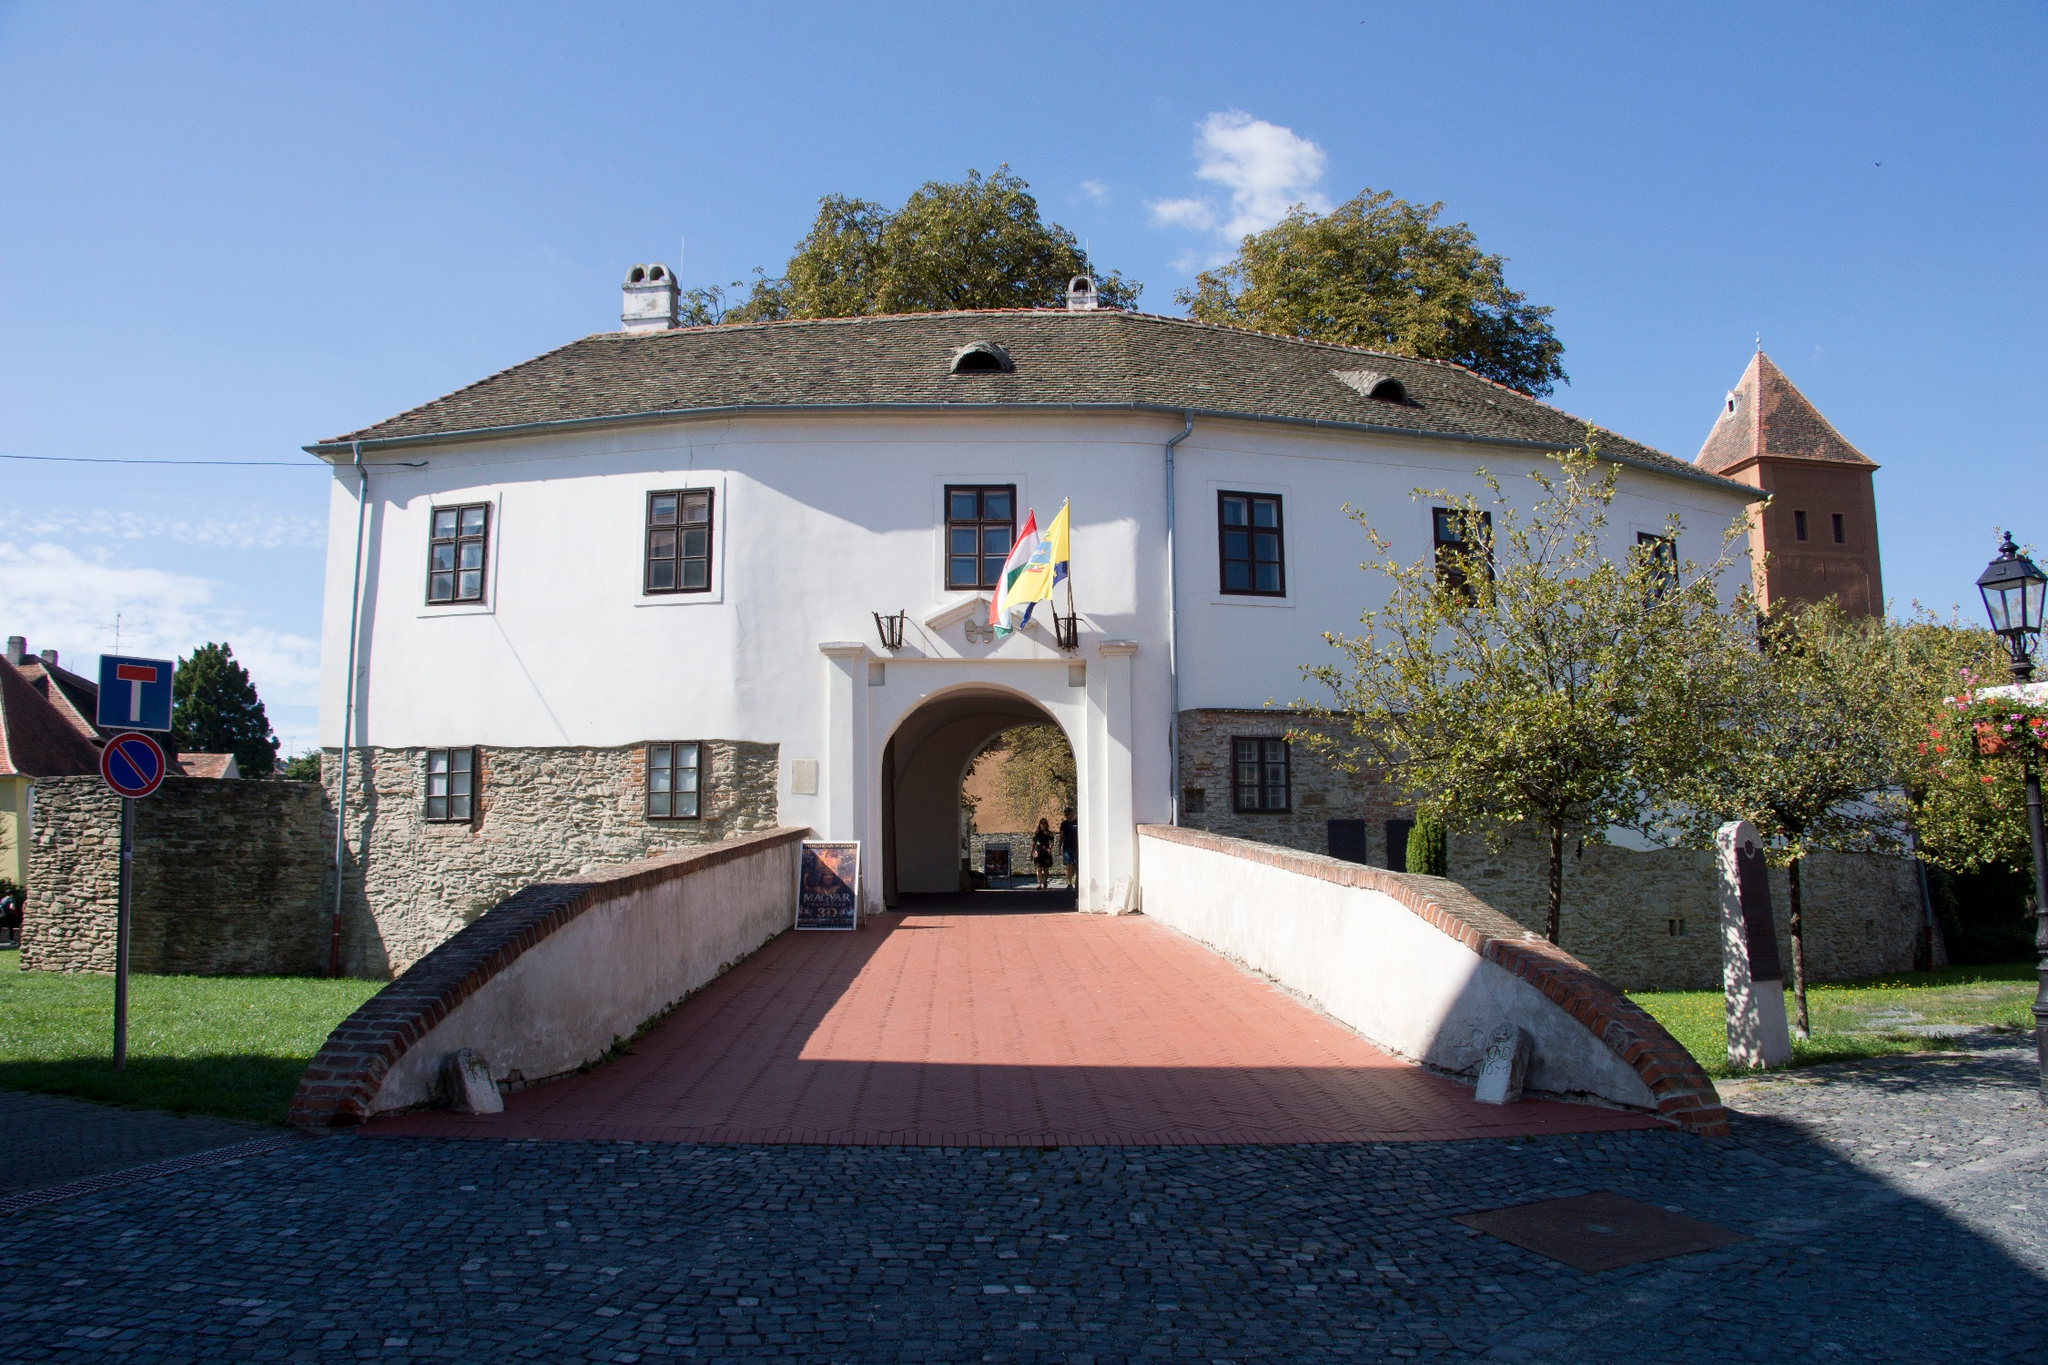Speculate on what hidden secrets this church might hold. Given the historic and fortified nature of the Prejmer church, it's tempting to speculate on the hidden secrets it might hold. Concealed passageways or tunnels could snake beneath the heavy stone foundations, remnants from times of siege when quick escapes were necessary. Within these passages, perhaps forgotten relics or artifacts from its medieval past lie undisturbed. Ancient texts or manuscripts, long thought lost, could be secreted away in hidden alcoves, containing esoteric knowledge or long-buried family secrets tied to the church's benefactors. There might also be cryptic carvings or symbols embedded within the stone itself, detailed records of significant events or messages meant only for the clergy. Such secrets could shed light not only on the church's storied past but also on the larger historical and sociopolitical landscape of the region. What might the role of this church be in a spy thriller? In a spy thriller, the Prejmer fortified church could serve as a critical rendezvous point or hideout for espionage activities. Beneath its austere, historical exterior, the church might harbor secret meeting rooms where agents exchange sensitive information under the guise of devout pilgrims. The thick stone walls would double as soundproof chambers, ideal for clandestine conversations. The church's labyrinthine passages and hidden nooks could be perfect for storing covert messages or smuggling contraband. A clever spy might use the church's regular influx of visitors to mask their movements, slipping between tourists and clergy alike. The red-brick walkway could witness hurried, coded exchanges or subtle handoffs of information as part of a larger web of intrigue. The historical aura of the church would provide a striking contrast to the modern, high-stakes espionage seamlessly unfolding within its archaic walls. 